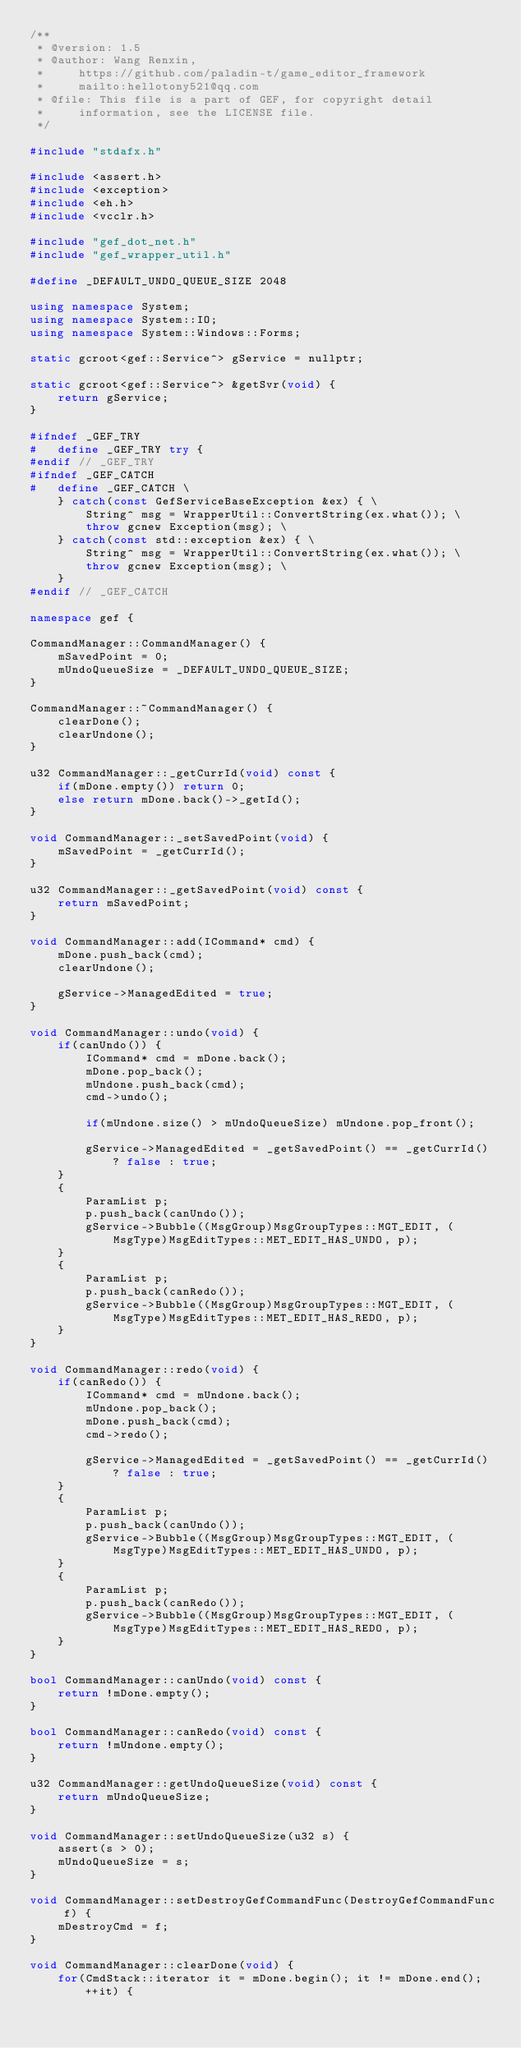Convert code to text. <code><loc_0><loc_0><loc_500><loc_500><_C++_>/**
 * @version: 1.5
 * @author: Wang Renxin,
 *     https://github.com/paladin-t/game_editor_framework
 *     mailto:hellotony521@qq.com
 * @file: This file is a part of GEF, for copyright detail
 *     information, see the LICENSE file.
 */

#include "stdafx.h"

#include <assert.h>
#include <exception>
#include <eh.h>
#include <vcclr.h>

#include "gef_dot_net.h"
#include "gef_wrapper_util.h"

#define _DEFAULT_UNDO_QUEUE_SIZE 2048

using namespace System;
using namespace System::IO;
using namespace System::Windows::Forms;

static gcroot<gef::Service^> gService = nullptr;

static gcroot<gef::Service^> &getSvr(void) {
	return gService;
}

#ifndef _GEF_TRY
#	define _GEF_TRY try {
#endif // _GEF_TRY
#ifndef _GEF_CATCH
#	define _GEF_CATCH \
	} catch(const GefServiceBaseException &ex) { \
		String^ msg = WrapperUtil::ConvertString(ex.what()); \
		throw gcnew Exception(msg); \
	} catch(const std::exception &ex) { \
		String^ msg = WrapperUtil::ConvertString(ex.what()); \
		throw gcnew Exception(msg); \
	}
#endif // _GEF_CATCH

namespace gef {

CommandManager::CommandManager() {
	mSavedPoint = 0;
	mUndoQueueSize = _DEFAULT_UNDO_QUEUE_SIZE;
}

CommandManager::~CommandManager() {
	clearDone();
	clearUndone();
}

u32 CommandManager::_getCurrId(void) const {
	if(mDone.empty()) return 0;
	else return mDone.back()->_getId();
}

void CommandManager::_setSavedPoint(void) {
	mSavedPoint = _getCurrId();
}

u32 CommandManager::_getSavedPoint(void) const {
	return mSavedPoint;
}

void CommandManager::add(ICommand* cmd) {
	mDone.push_back(cmd);
	clearUndone();

	gService->ManagedEdited = true;
}

void CommandManager::undo(void) {
	if(canUndo()) {
		ICommand* cmd = mDone.back();
		mDone.pop_back();
		mUndone.push_back(cmd);
		cmd->undo();

		if(mUndone.size() > mUndoQueueSize) mUndone.pop_front();

		gService->ManagedEdited = _getSavedPoint() == _getCurrId() ? false : true;
	}
	{
		ParamList p;
		p.push_back(canUndo());
		gService->Bubble((MsgGroup)MsgGroupTypes::MGT_EDIT, (MsgType)MsgEditTypes::MET_EDIT_HAS_UNDO, p);
	}
	{
		ParamList p;
		p.push_back(canRedo());
		gService->Bubble((MsgGroup)MsgGroupTypes::MGT_EDIT, (MsgType)MsgEditTypes::MET_EDIT_HAS_REDO, p);
	}
}

void CommandManager::redo(void) {
	if(canRedo()) {
		ICommand* cmd = mUndone.back();
		mUndone.pop_back();
		mDone.push_back(cmd);
		cmd->redo();

		gService->ManagedEdited = _getSavedPoint() == _getCurrId() ? false : true;
	}
	{
		ParamList p;
		p.push_back(canUndo());
		gService->Bubble((MsgGroup)MsgGroupTypes::MGT_EDIT, (MsgType)MsgEditTypes::MET_EDIT_HAS_UNDO, p);
	}
	{
		ParamList p;
		p.push_back(canRedo());
		gService->Bubble((MsgGroup)MsgGroupTypes::MGT_EDIT, (MsgType)MsgEditTypes::MET_EDIT_HAS_REDO, p);
	}
}

bool CommandManager::canUndo(void) const {
	return !mDone.empty();
}

bool CommandManager::canRedo(void) const {
	return !mUndone.empty();
}

u32 CommandManager::getUndoQueueSize(void) const {
	return mUndoQueueSize;
}

void CommandManager::setUndoQueueSize(u32 s) {
	assert(s > 0);
	mUndoQueueSize = s;
}

void CommandManager::setDestroyGefCommandFunc(DestroyGefCommandFunc f) {
	mDestroyCmd = f;
}

void CommandManager::clearDone(void) {
	for(CmdStack::iterator it = mDone.begin(); it != mDone.end(); ++it) {</code> 